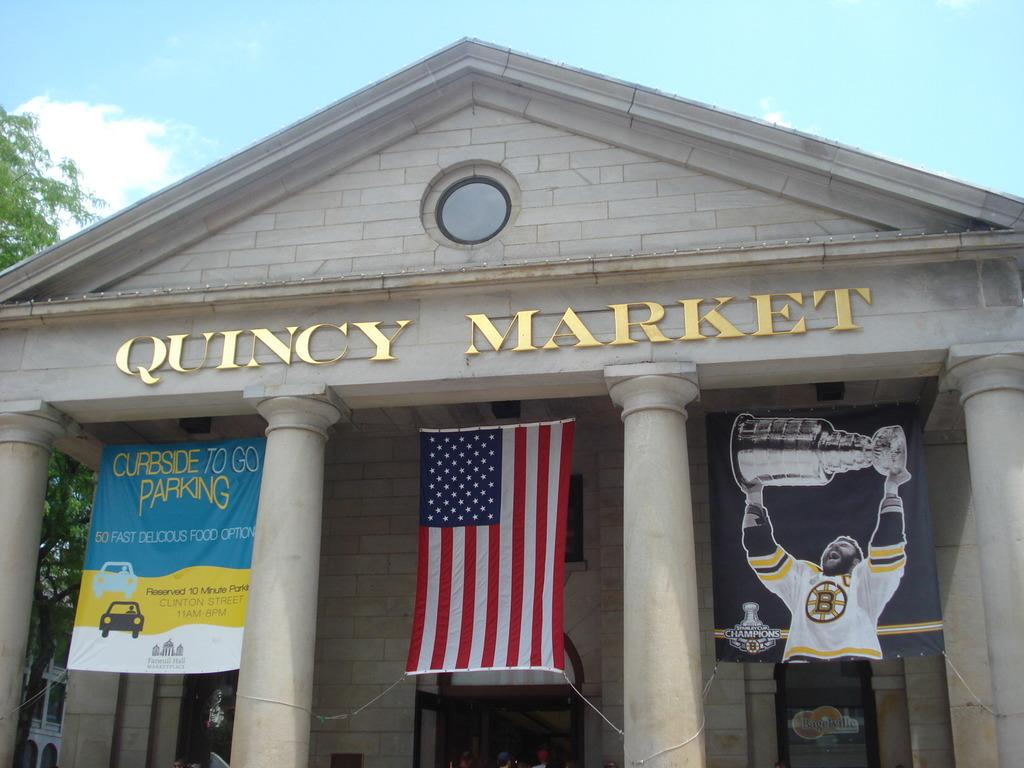<image>
Describe the image concisely. Banners and the American flag hang between the columns of Quincy Market. 